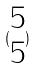<formula> <loc_0><loc_0><loc_500><loc_500>( \begin{matrix} 5 \\ 5 \end{matrix} )</formula> 